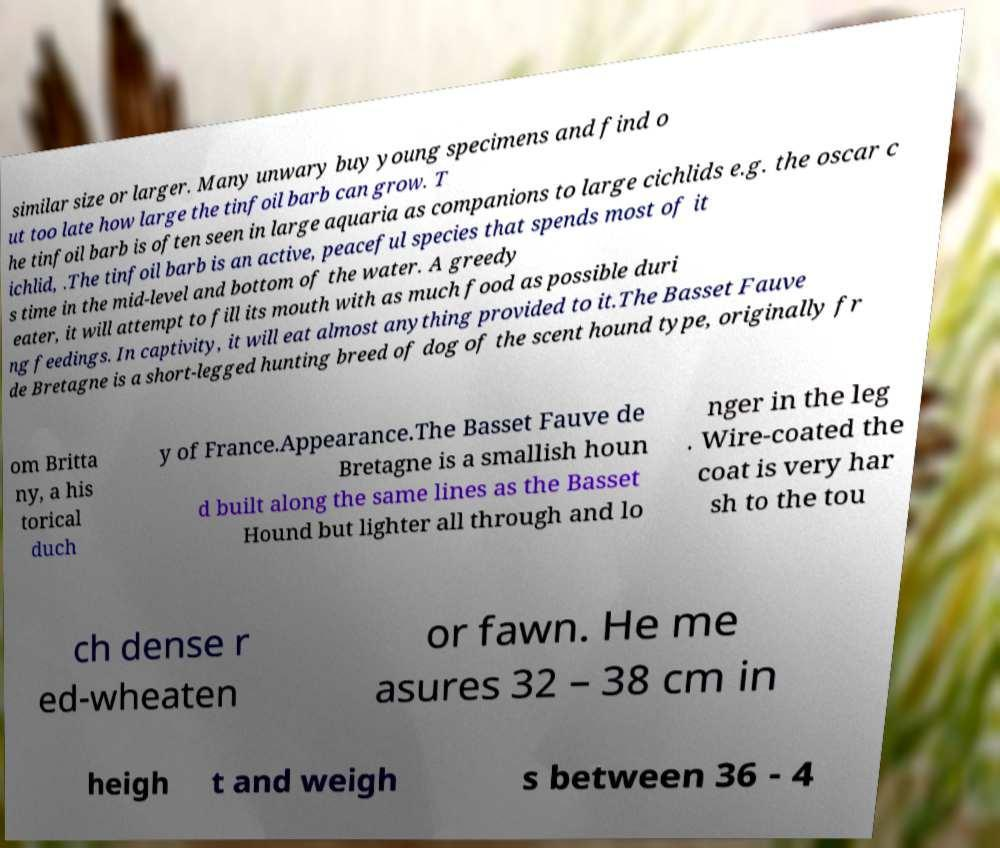Can you accurately transcribe the text from the provided image for me? similar size or larger. Many unwary buy young specimens and find o ut too late how large the tinfoil barb can grow. T he tinfoil barb is often seen in large aquaria as companions to large cichlids e.g. the oscar c ichlid, .The tinfoil barb is an active, peaceful species that spends most of it s time in the mid-level and bottom of the water. A greedy eater, it will attempt to fill its mouth with as much food as possible duri ng feedings. In captivity, it will eat almost anything provided to it.The Basset Fauve de Bretagne is a short-legged hunting breed of dog of the scent hound type, originally fr om Britta ny, a his torical duch y of France.Appearance.The Basset Fauve de Bretagne is a smallish houn d built along the same lines as the Basset Hound but lighter all through and lo nger in the leg . Wire-coated the coat is very har sh to the tou ch dense r ed-wheaten or fawn. He me asures 32 – 38 cm in heigh t and weigh s between 36 - 4 